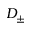<formula> <loc_0><loc_0><loc_500><loc_500>D _ { \pm }</formula> 